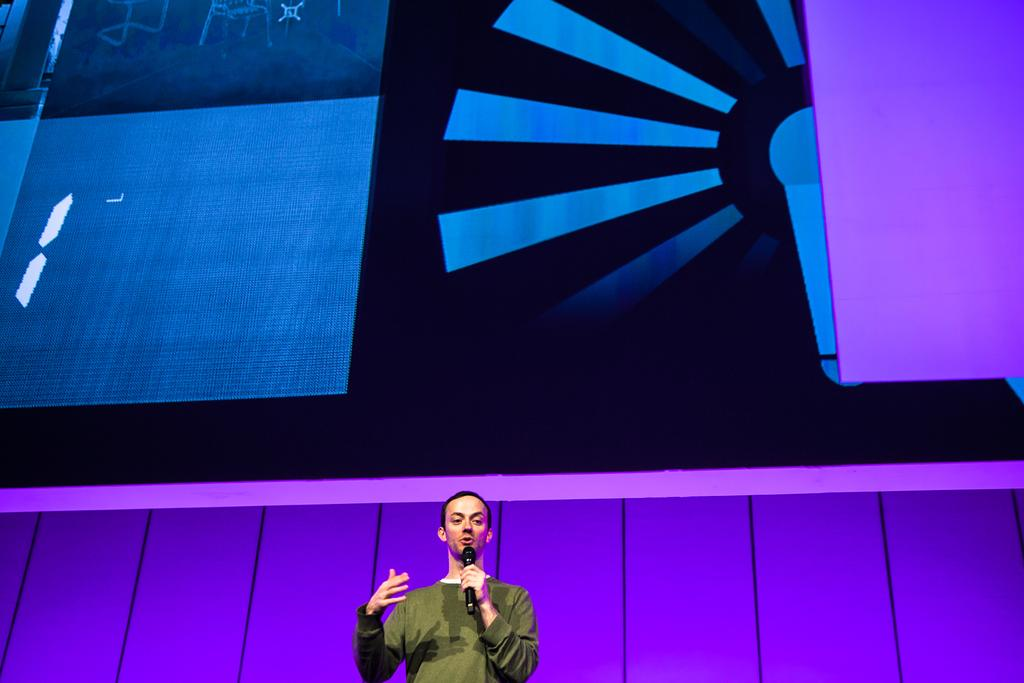Who is the person in the image? There is a man in the image. What is the man holding in the image? The man is holding a microphone. What is the man wearing in the image? The man is wearing a green t-shirt. What can be seen in the background of the image? There are designs visible in the background of the image. What type of hook is the man using to catch fish in the image? There is no hook or fishing activity present in the image; the man is holding a microphone. 